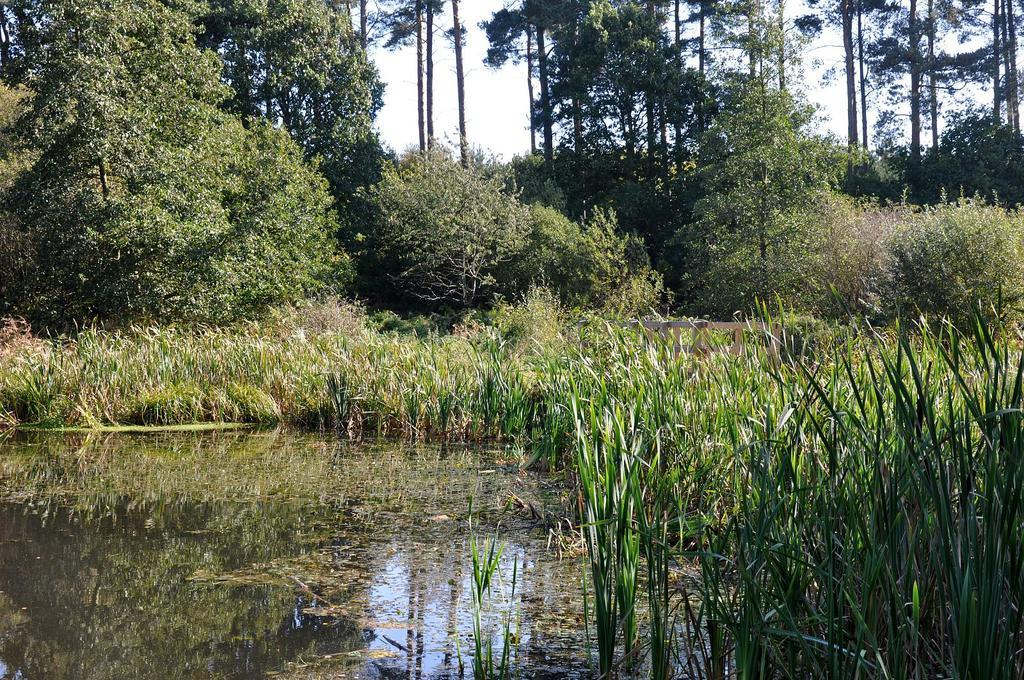What type of vegetation can be seen in the image? There are trees and plants in the image. What natural element is visible in the image? Water is visible in the image. What part of the natural environment is visible in the image? The sky is visible in the image. Can you describe the alley where the turkey is walking in the image? There is no alley or turkey present in the image; it features trees, plants, water, and the sky. 